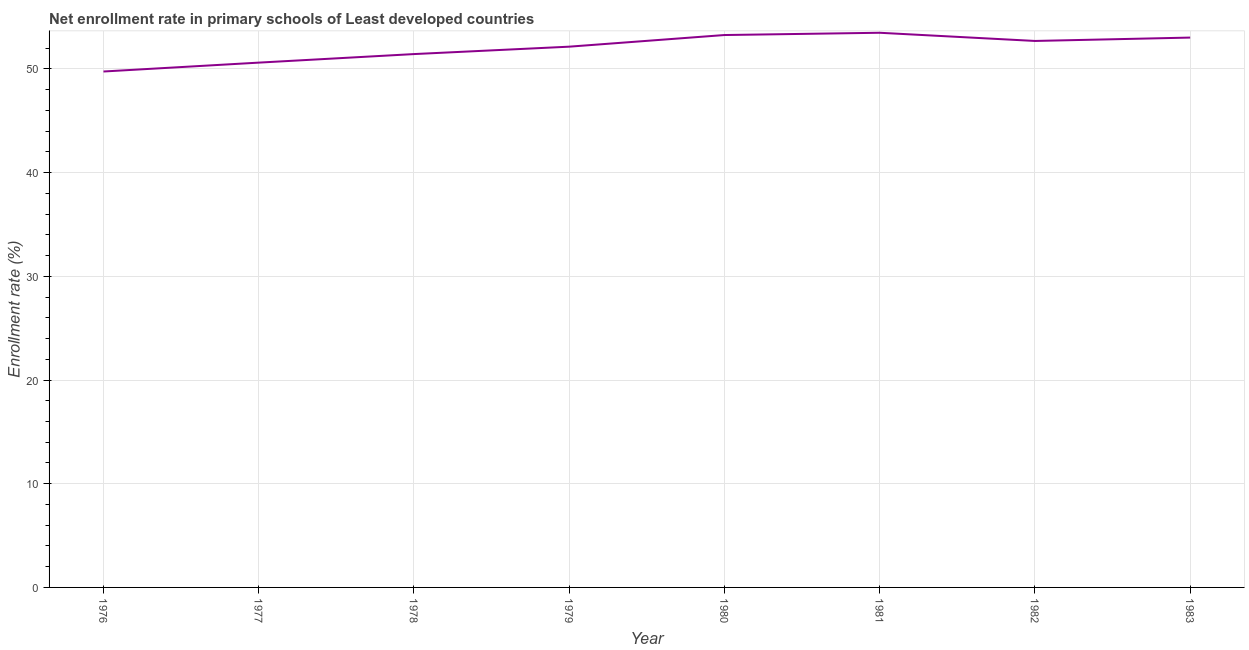What is the net enrollment rate in primary schools in 1979?
Your answer should be very brief. 52.14. Across all years, what is the maximum net enrollment rate in primary schools?
Your answer should be very brief. 53.48. Across all years, what is the minimum net enrollment rate in primary schools?
Provide a short and direct response. 49.75. In which year was the net enrollment rate in primary schools maximum?
Your answer should be very brief. 1981. In which year was the net enrollment rate in primary schools minimum?
Offer a terse response. 1976. What is the sum of the net enrollment rate in primary schools?
Offer a very short reply. 416.37. What is the difference between the net enrollment rate in primary schools in 1982 and 1983?
Your response must be concise. -0.33. What is the average net enrollment rate in primary schools per year?
Provide a succinct answer. 52.05. What is the median net enrollment rate in primary schools?
Keep it short and to the point. 52.42. In how many years, is the net enrollment rate in primary schools greater than 44 %?
Keep it short and to the point. 8. Do a majority of the years between 1979 and 1982 (inclusive) have net enrollment rate in primary schools greater than 24 %?
Provide a short and direct response. Yes. What is the ratio of the net enrollment rate in primary schools in 1976 to that in 1982?
Offer a terse response. 0.94. Is the net enrollment rate in primary schools in 1979 less than that in 1983?
Your response must be concise. Yes. Is the difference between the net enrollment rate in primary schools in 1977 and 1983 greater than the difference between any two years?
Give a very brief answer. No. What is the difference between the highest and the second highest net enrollment rate in primary schools?
Make the answer very short. 0.22. Is the sum of the net enrollment rate in primary schools in 1979 and 1982 greater than the maximum net enrollment rate in primary schools across all years?
Make the answer very short. Yes. What is the difference between the highest and the lowest net enrollment rate in primary schools?
Provide a short and direct response. 3.74. In how many years, is the net enrollment rate in primary schools greater than the average net enrollment rate in primary schools taken over all years?
Provide a succinct answer. 5. Does the net enrollment rate in primary schools monotonically increase over the years?
Keep it short and to the point. No. How many years are there in the graph?
Your answer should be compact. 8. Are the values on the major ticks of Y-axis written in scientific E-notation?
Provide a succinct answer. No. Does the graph contain grids?
Provide a succinct answer. Yes. What is the title of the graph?
Your answer should be very brief. Net enrollment rate in primary schools of Least developed countries. What is the label or title of the X-axis?
Ensure brevity in your answer.  Year. What is the label or title of the Y-axis?
Your response must be concise. Enrollment rate (%). What is the Enrollment rate (%) of 1976?
Provide a succinct answer. 49.75. What is the Enrollment rate (%) of 1977?
Ensure brevity in your answer.  50.6. What is the Enrollment rate (%) in 1978?
Give a very brief answer. 51.43. What is the Enrollment rate (%) in 1979?
Your answer should be very brief. 52.14. What is the Enrollment rate (%) in 1980?
Give a very brief answer. 53.26. What is the Enrollment rate (%) in 1981?
Provide a succinct answer. 53.48. What is the Enrollment rate (%) in 1982?
Offer a terse response. 52.69. What is the Enrollment rate (%) of 1983?
Your answer should be very brief. 53.02. What is the difference between the Enrollment rate (%) in 1976 and 1977?
Provide a succinct answer. -0.86. What is the difference between the Enrollment rate (%) in 1976 and 1978?
Provide a short and direct response. -1.68. What is the difference between the Enrollment rate (%) in 1976 and 1979?
Offer a terse response. -2.4. What is the difference between the Enrollment rate (%) in 1976 and 1980?
Give a very brief answer. -3.52. What is the difference between the Enrollment rate (%) in 1976 and 1981?
Provide a short and direct response. -3.74. What is the difference between the Enrollment rate (%) in 1976 and 1982?
Your response must be concise. -2.95. What is the difference between the Enrollment rate (%) in 1976 and 1983?
Provide a succinct answer. -3.27. What is the difference between the Enrollment rate (%) in 1977 and 1978?
Ensure brevity in your answer.  -0.82. What is the difference between the Enrollment rate (%) in 1977 and 1979?
Give a very brief answer. -1.54. What is the difference between the Enrollment rate (%) in 1977 and 1980?
Offer a terse response. -2.66. What is the difference between the Enrollment rate (%) in 1977 and 1981?
Provide a short and direct response. -2.88. What is the difference between the Enrollment rate (%) in 1977 and 1982?
Your answer should be compact. -2.09. What is the difference between the Enrollment rate (%) in 1977 and 1983?
Give a very brief answer. -2.41. What is the difference between the Enrollment rate (%) in 1978 and 1979?
Ensure brevity in your answer.  -0.71. What is the difference between the Enrollment rate (%) in 1978 and 1980?
Your answer should be compact. -1.84. What is the difference between the Enrollment rate (%) in 1978 and 1981?
Your answer should be compact. -2.05. What is the difference between the Enrollment rate (%) in 1978 and 1982?
Ensure brevity in your answer.  -1.26. What is the difference between the Enrollment rate (%) in 1978 and 1983?
Make the answer very short. -1.59. What is the difference between the Enrollment rate (%) in 1979 and 1980?
Offer a terse response. -1.12. What is the difference between the Enrollment rate (%) in 1979 and 1981?
Make the answer very short. -1.34. What is the difference between the Enrollment rate (%) in 1979 and 1982?
Make the answer very short. -0.55. What is the difference between the Enrollment rate (%) in 1979 and 1983?
Your answer should be very brief. -0.88. What is the difference between the Enrollment rate (%) in 1980 and 1981?
Your answer should be very brief. -0.22. What is the difference between the Enrollment rate (%) in 1980 and 1982?
Offer a terse response. 0.57. What is the difference between the Enrollment rate (%) in 1980 and 1983?
Keep it short and to the point. 0.25. What is the difference between the Enrollment rate (%) in 1981 and 1982?
Ensure brevity in your answer.  0.79. What is the difference between the Enrollment rate (%) in 1981 and 1983?
Your response must be concise. 0.46. What is the difference between the Enrollment rate (%) in 1982 and 1983?
Offer a terse response. -0.33. What is the ratio of the Enrollment rate (%) in 1976 to that in 1977?
Your response must be concise. 0.98. What is the ratio of the Enrollment rate (%) in 1976 to that in 1978?
Provide a succinct answer. 0.97. What is the ratio of the Enrollment rate (%) in 1976 to that in 1979?
Offer a very short reply. 0.95. What is the ratio of the Enrollment rate (%) in 1976 to that in 1980?
Ensure brevity in your answer.  0.93. What is the ratio of the Enrollment rate (%) in 1976 to that in 1982?
Your response must be concise. 0.94. What is the ratio of the Enrollment rate (%) in 1976 to that in 1983?
Offer a terse response. 0.94. What is the ratio of the Enrollment rate (%) in 1977 to that in 1978?
Give a very brief answer. 0.98. What is the ratio of the Enrollment rate (%) in 1977 to that in 1981?
Provide a succinct answer. 0.95. What is the ratio of the Enrollment rate (%) in 1977 to that in 1983?
Make the answer very short. 0.95. What is the ratio of the Enrollment rate (%) in 1978 to that in 1979?
Keep it short and to the point. 0.99. What is the ratio of the Enrollment rate (%) in 1978 to that in 1981?
Your response must be concise. 0.96. What is the ratio of the Enrollment rate (%) in 1978 to that in 1982?
Your response must be concise. 0.98. What is the ratio of the Enrollment rate (%) in 1978 to that in 1983?
Give a very brief answer. 0.97. What is the ratio of the Enrollment rate (%) in 1979 to that in 1980?
Offer a terse response. 0.98. What is the ratio of the Enrollment rate (%) in 1979 to that in 1983?
Offer a terse response. 0.98. What is the ratio of the Enrollment rate (%) in 1980 to that in 1981?
Your answer should be compact. 1. What is the ratio of the Enrollment rate (%) in 1980 to that in 1983?
Your answer should be very brief. 1. What is the ratio of the Enrollment rate (%) in 1981 to that in 1982?
Provide a succinct answer. 1.01. 